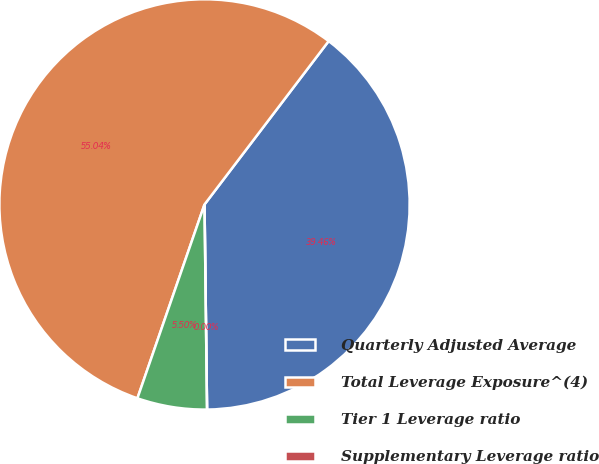Convert chart. <chart><loc_0><loc_0><loc_500><loc_500><pie_chart><fcel>Quarterly Adjusted Average<fcel>Total Leverage Exposure^(4)<fcel>Tier 1 Leverage ratio<fcel>Supplementary Leverage ratio<nl><fcel>39.46%<fcel>55.04%<fcel>5.5%<fcel>0.0%<nl></chart> 